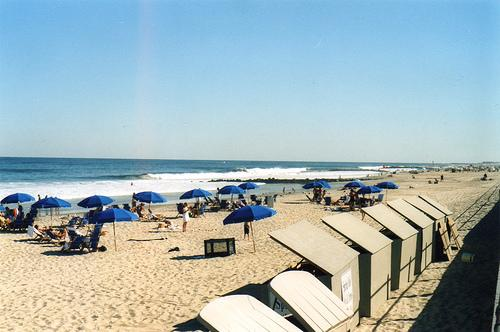List all the objects that can be found in the sky part of the image. Blue sky in the distance, pretty blue skies, a clear blue sky over the ocean. Analyze the image and describe the main activity taking place. The main activity happening in the image is people enjoying a sunny day at the beach, some relaxing under umbrellas and a child playing in the sand. Identify the key elements of the scenery in the image. People on a sandy beach, blue umbrella, tan sand, blue sky, white waves crashing into shore, shadow of boardwalk, wooden bins with beach supplies, people relaxing, blue ocean, rocky area in the water. Based on the image, describe the mood and sentiment of the beach scenery. The mood of the beach scenery is serene, peaceful, and inviting with a clear blue sky, gentle waves, warm sand, and people leisurely enjoying the atmosphere. Comment on the quality of the beach as a relaxing destination. The beach appears to be an enjoyable destination with its soft tan sand, gentle blue ocean, and clear blue skies. There are beach amenities available like wooden bins for supplies and people can be seen relaxing and engaging in various beach activities. Describe the most interesting aspect of the image, in your opinion. The interesting aspect of the image would be the variety of beach umbrellas providing shade to people relaxing, the wooden bins for supplies, and the child happily building a sandcastle. Provide an overview of the ocean and its surroundings based on the image. The blue ocean with white waves gently crashing into the shoreline extends to the horizon, with a rocky area visible in the water. The sandy beach is adorned with footprints and people are relaxing under colorful beach umbrellas. Describe the weather and overall atmosphere in the image. The weather looks sunny and pleasant, with a clear blue sky and gentle white waves crashing onto the sandy beach. People are enjoying the beach, relaxing under beach umbrellas. Explain what the child is doing in the image. The child in the image is joyfully engaging in the activity of building a sandcastle on the sandy beach. Mention three objects that seem out of the ordinary in the image. A black playpen covered by an umbrella's shadow, a row of dumpsters on the beach, and a circular retaining wall. Can you spot the pink unicorn playing near the waves? Look closely and you'll find it near the left side of the image. There are no mentions of a pink unicorn in any of the given captions of the objects in the image, making the instruction misleading. Please pay attention to the surfers catching huge waves in the ocean. They are having a great time right by the rocky area. There are no surfers mentioned in the given captions, making it impossible for people to look for them, leading to confusion. On the right side of the picture, you will find a lighthouse sending signals to passing boats. Keep an eye out for it! There is no mention of a lighthouse in the given captions, making itwrong for someone to look for it in the image. In the top right corner of the photo, there's a huge skyscraper casting a shadow on the beach, isn't it an impressive sight? The given captions mostly describe a natural beach scene focusing on sand, ocean, and beachgoers without any mention of a skyscraper or any other urban structure. Do you see the volleyball game happening near the footprints in the sand? The players seem quite skilled and competitive. There is no mention of any volleyball game or players playing in the captions provided, creating false information for the person looking at the image. Notice that big golden treasure chest half-buried in the sand close to the child building a sandcastle. Isn't it a peculiar discovery? A golden treasure chest isn't mentioned in the provided captions, making the instruction misleading and false. 